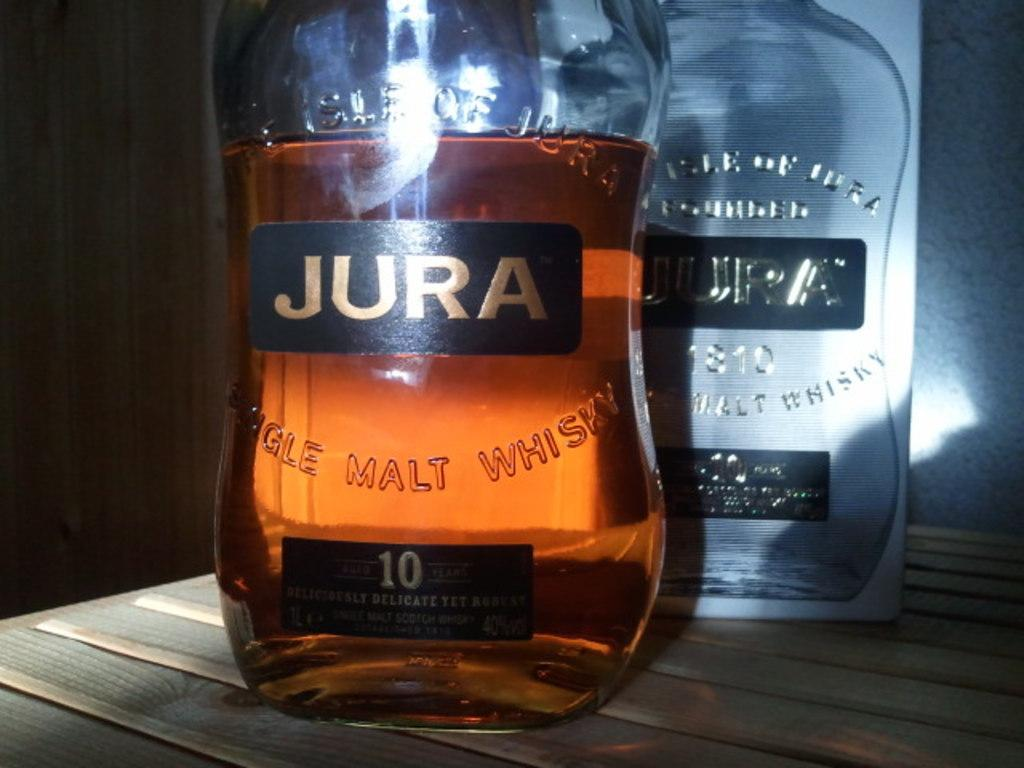<image>
Render a clear and concise summary of the photo. Two bottles one empty one half full of malt whiskey called Jura. 